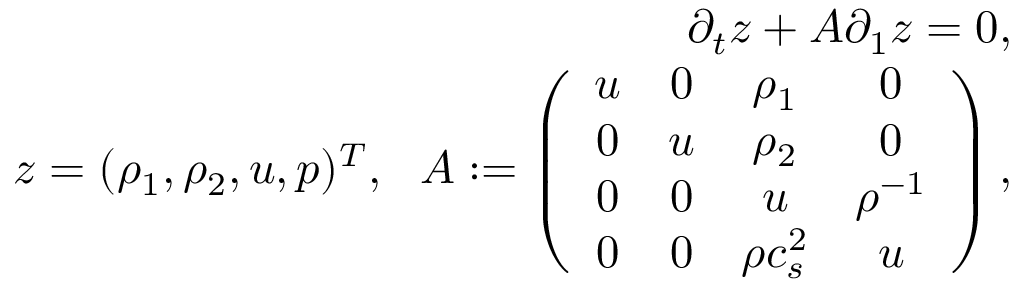<formula> <loc_0><loc_0><loc_500><loc_500>\begin{array} { r } { \partial _ { t } z + A \partial _ { 1 } z = 0 , } \\ { z = ( \rho _ { 1 } , \rho _ { 2 } , u , p ) ^ { T } , \ \ A \colon = \left ( \begin{array} { c c c c } { u } & { 0 } & { \rho _ { 1 } } & { 0 } \\ { 0 } & { u } & { \rho _ { 2 } } & { 0 } \\ { 0 } & { 0 } & { u } & { \rho ^ { - 1 } } \\ { 0 } & { 0 } & { \rho c _ { s } ^ { 2 } } & { u } \end{array} \right ) , } \end{array}</formula> 